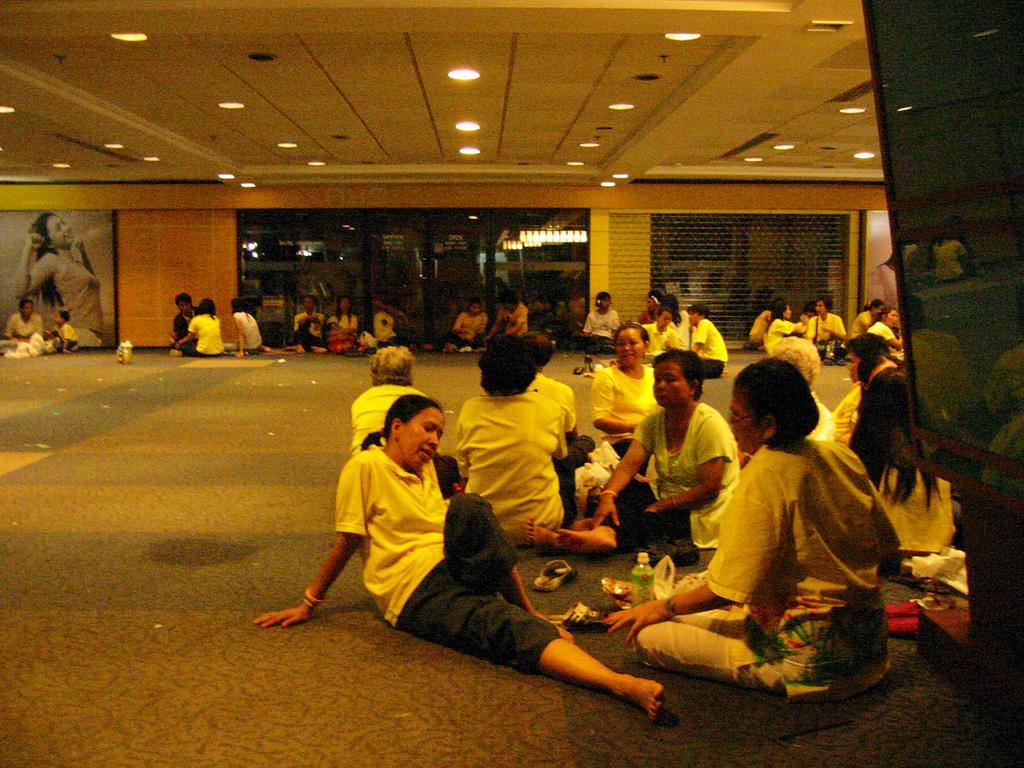Could you give a brief overview of what you see in this image? Here in this picture we can see number of groups of women sitting on the floor and on the roof we can see lights present and we can see some posters on the wall and in the middle we can see glass door present and on that we can see reflection of chandeliers and lights present. 